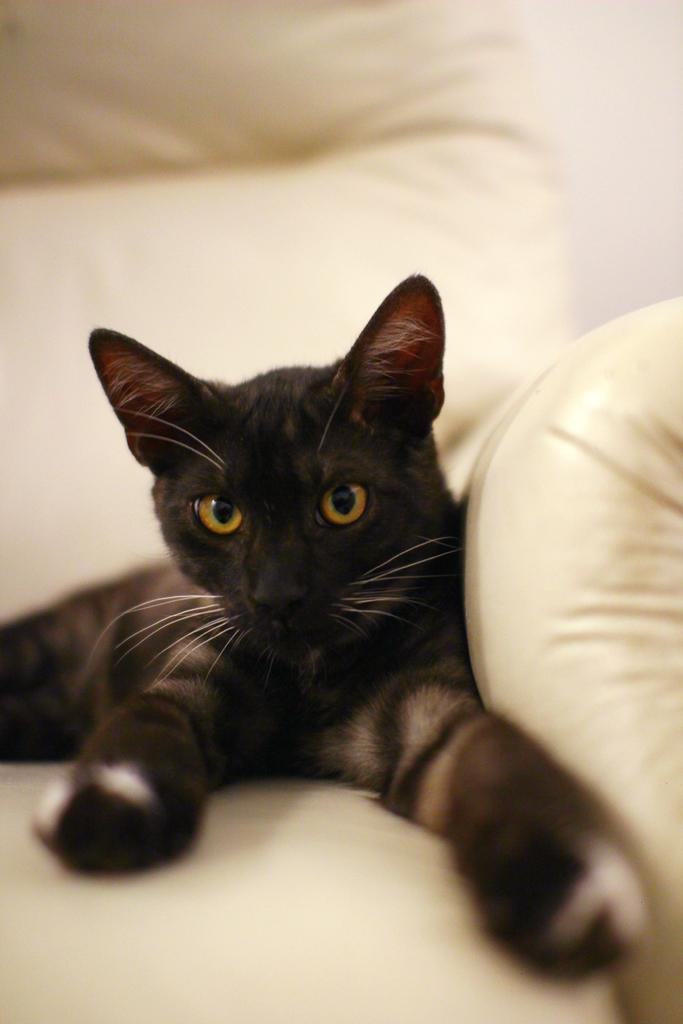What type of animal is in the image? There is a black cat in the image. Where is the black cat sitting? The black cat is sitting on a white couch. What type of pies can be seen in the image? There are no pies present in the image; it features a black cat sitting on a white couch. What does the black cat taste like in the image? The image does not provide any information about the taste of the black cat, as it is a visual representation. 